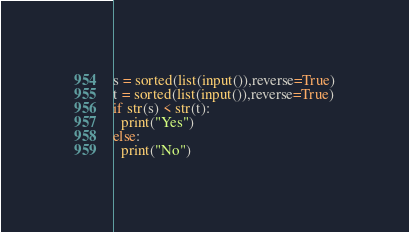<code> <loc_0><loc_0><loc_500><loc_500><_Python_>s = sorted(list(input()),reverse=True)
t = sorted(list(input()),reverse=True)
if str(s) < str(t):
  print("Yes")
else:
  print("No")</code> 